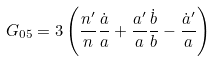Convert formula to latex. <formula><loc_0><loc_0><loc_500><loc_500>G _ { 0 5 } = 3 \left ( \frac { n ^ { \prime } } { n } \frac { \dot { a } } { a } + \frac { a ^ { \prime } } { a } \frac { \dot { b } } { b } - \frac { \dot { a } ^ { \prime } } { a } \right )</formula> 